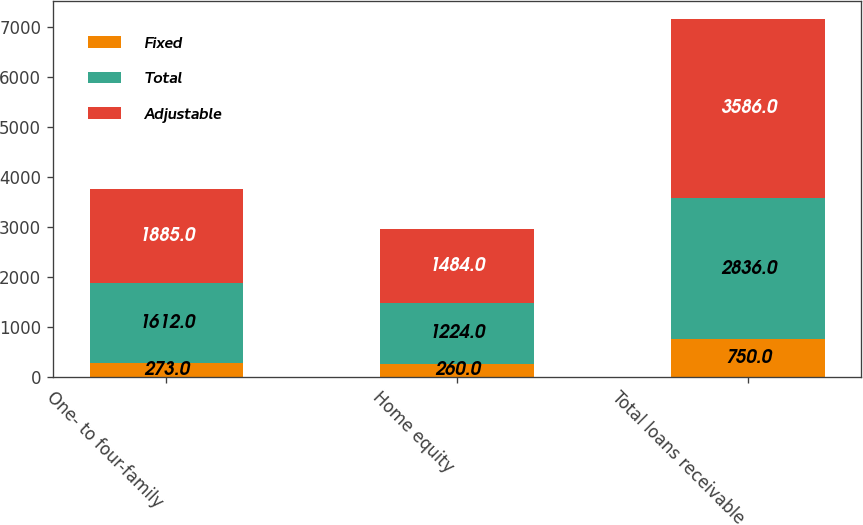Convert chart. <chart><loc_0><loc_0><loc_500><loc_500><stacked_bar_chart><ecel><fcel>One- to four-family<fcel>Home equity<fcel>Total loans receivable<nl><fcel>Fixed<fcel>273<fcel>260<fcel>750<nl><fcel>Total<fcel>1612<fcel>1224<fcel>2836<nl><fcel>Adjustable<fcel>1885<fcel>1484<fcel>3586<nl></chart> 